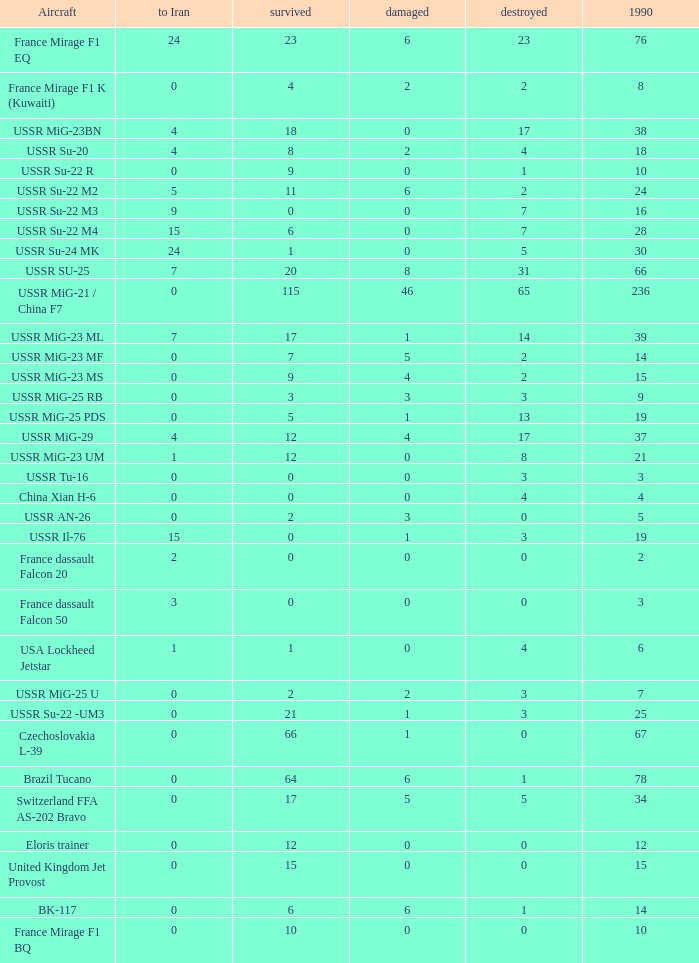If there were 14 in 1990 and 6 survived how many were destroyed? 1.0. 